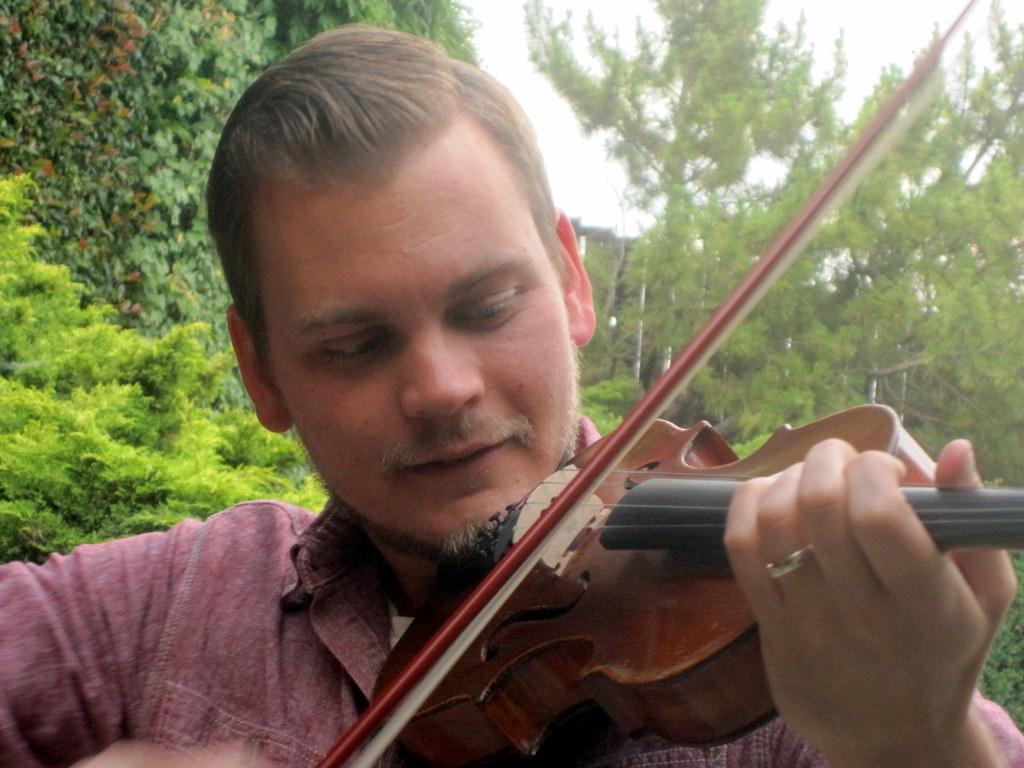Please provide a concise description of this image. Here we can see a man playing a violin and behind him we can see trees 